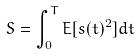<formula> <loc_0><loc_0><loc_500><loc_500>S = \int _ { 0 } ^ { T } E [ s ( t ) ^ { 2 } ] d t</formula> 